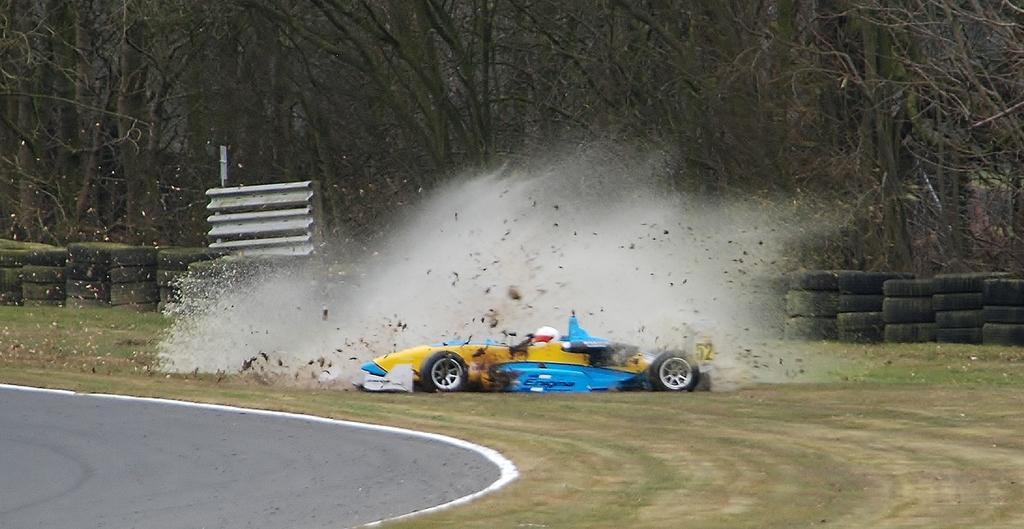Please provide a concise description of this image. In this image we can see a person sitting in a car placed on the grass. We can also see some smoke and dust around the car. On the backside we can see some group of trees, tires which are kept in a rows and a road. 